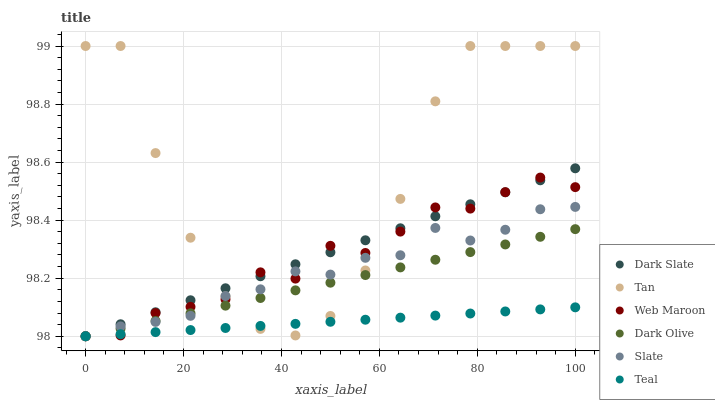Does Teal have the minimum area under the curve?
Answer yes or no. Yes. Does Tan have the maximum area under the curve?
Answer yes or no. Yes. Does Dark Olive have the minimum area under the curve?
Answer yes or no. No. Does Dark Olive have the maximum area under the curve?
Answer yes or no. No. Is Teal the smoothest?
Answer yes or no. Yes. Is Tan the roughest?
Answer yes or no. Yes. Is Dark Olive the smoothest?
Answer yes or no. No. Is Dark Olive the roughest?
Answer yes or no. No. Does Slate have the lowest value?
Answer yes or no. Yes. Does Tan have the lowest value?
Answer yes or no. No. Does Tan have the highest value?
Answer yes or no. Yes. Does Dark Olive have the highest value?
Answer yes or no. No. Does Dark Olive intersect Teal?
Answer yes or no. Yes. Is Dark Olive less than Teal?
Answer yes or no. No. Is Dark Olive greater than Teal?
Answer yes or no. No. 